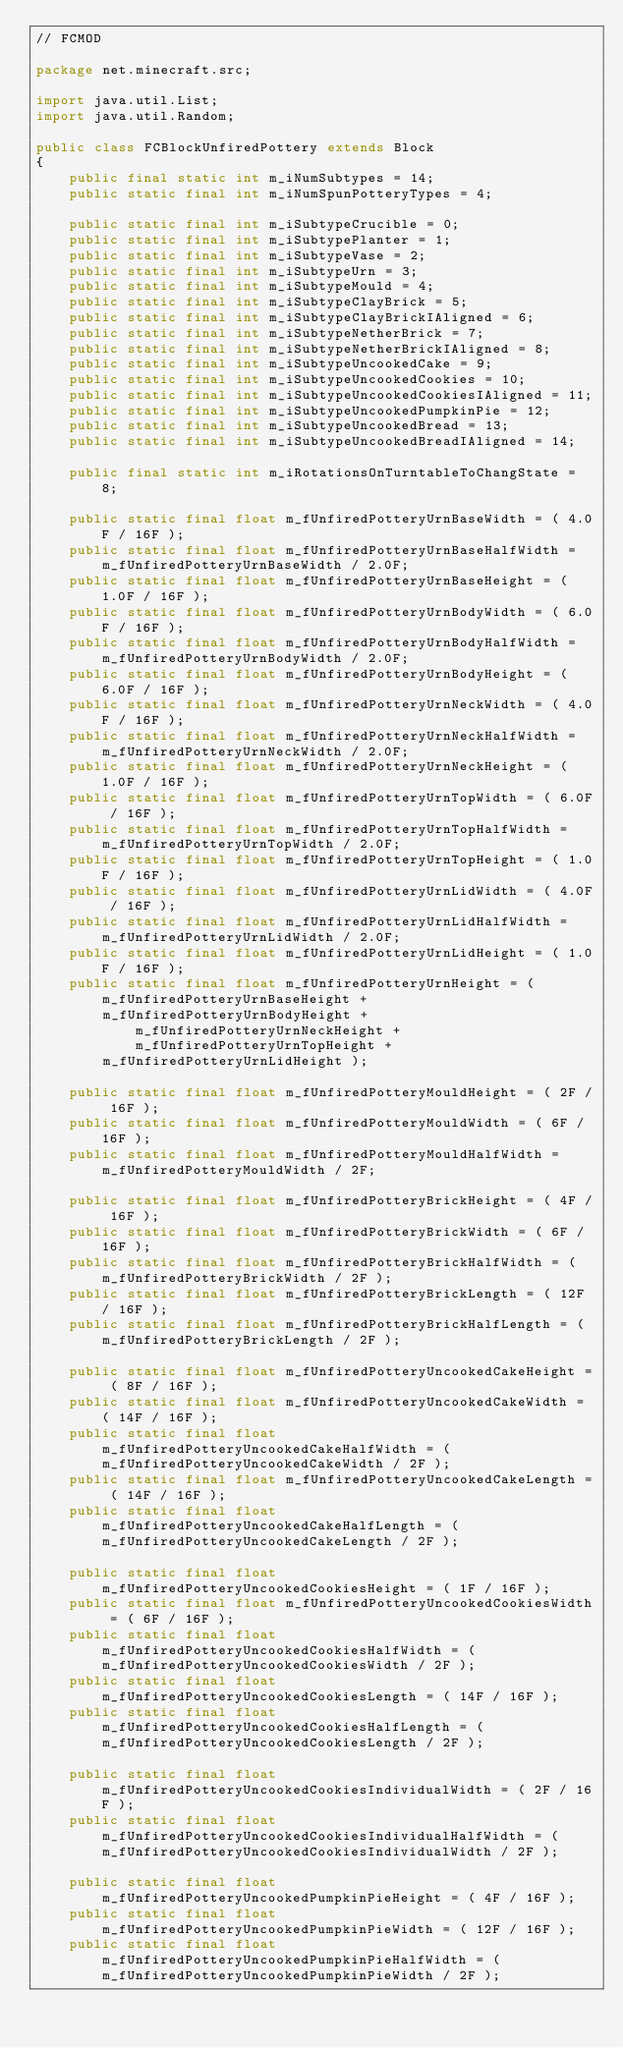Convert code to text. <code><loc_0><loc_0><loc_500><loc_500><_Java_>// FCMOD

package net.minecraft.src;

import java.util.List;
import java.util.Random;

public class FCBlockUnfiredPottery extends Block
{
    public final static int m_iNumSubtypes = 14;
    public static final int m_iNumSpunPotteryTypes = 4;    
    
    public static final int m_iSubtypeCrucible = 0;
    public static final int m_iSubtypePlanter = 1;
    public static final int m_iSubtypeVase = 2;
    public static final int m_iSubtypeUrn = 3;
    public static final int m_iSubtypeMould = 4;
    public static final int m_iSubtypeClayBrick = 5;
    public static final int m_iSubtypeClayBrickIAligned = 6;
    public static final int m_iSubtypeNetherBrick = 7;
    public static final int m_iSubtypeNetherBrickIAligned = 8;
    public static final int m_iSubtypeUncookedCake = 9;
    public static final int m_iSubtypeUncookedCookies = 10;
    public static final int m_iSubtypeUncookedCookiesIAligned = 11;
    public static final int m_iSubtypeUncookedPumpkinPie = 12;
    public static final int m_iSubtypeUncookedBread = 13;
    public static final int m_iSubtypeUncookedBreadIAligned = 14;
    
    public final static int m_iRotationsOnTurntableToChangState = 8;
    
	public static final float m_fUnfiredPotteryUrnBaseWidth = ( 4.0F / 16F );
	public static final float m_fUnfiredPotteryUrnBaseHalfWidth = m_fUnfiredPotteryUrnBaseWidth / 2.0F;
	public static final float m_fUnfiredPotteryUrnBaseHeight = ( 1.0F / 16F );
	public static final float m_fUnfiredPotteryUrnBodyWidth = ( 6.0F / 16F );
	public static final float m_fUnfiredPotteryUrnBodyHalfWidth = m_fUnfiredPotteryUrnBodyWidth / 2.0F;
	public static final float m_fUnfiredPotteryUrnBodyHeight = ( 6.0F / 16F );
	public static final float m_fUnfiredPotteryUrnNeckWidth = ( 4.0F / 16F );
	public static final float m_fUnfiredPotteryUrnNeckHalfWidth = m_fUnfiredPotteryUrnNeckWidth / 2.0F;
	public static final float m_fUnfiredPotteryUrnNeckHeight = ( 1.0F / 16F );
	public static final float m_fUnfiredPotteryUrnTopWidth = ( 6.0F / 16F );
	public static final float m_fUnfiredPotteryUrnTopHalfWidth = m_fUnfiredPotteryUrnTopWidth / 2.0F;
	public static final float m_fUnfiredPotteryUrnTopHeight = ( 1.0F / 16F );
	public static final float m_fUnfiredPotteryUrnLidWidth = ( 4.0F / 16F );
	public static final float m_fUnfiredPotteryUrnLidHalfWidth = m_fUnfiredPotteryUrnLidWidth / 2.0F;
	public static final float m_fUnfiredPotteryUrnLidHeight = ( 1.0F / 16F );
	public static final float m_fUnfiredPotteryUrnHeight = ( m_fUnfiredPotteryUrnBaseHeight + 
		m_fUnfiredPotteryUrnBodyHeight + m_fUnfiredPotteryUrnNeckHeight + m_fUnfiredPotteryUrnTopHeight +
		m_fUnfiredPotteryUrnLidHeight );
	
	public static final float m_fUnfiredPotteryMouldHeight = ( 2F / 16F );
	public static final float m_fUnfiredPotteryMouldWidth = ( 6F / 16F );
	public static final float m_fUnfiredPotteryMouldHalfWidth = m_fUnfiredPotteryMouldWidth / 2F;
	
	public static final float m_fUnfiredPotteryBrickHeight = ( 4F / 16F );
	public static final float m_fUnfiredPotteryBrickWidth = ( 6F / 16F );
	public static final float m_fUnfiredPotteryBrickHalfWidth = ( m_fUnfiredPotteryBrickWidth / 2F );
	public static final float m_fUnfiredPotteryBrickLength = ( 12F / 16F );
	public static final float m_fUnfiredPotteryBrickHalfLength = ( m_fUnfiredPotteryBrickLength / 2F );
	
	public static final float m_fUnfiredPotteryUncookedCakeHeight = ( 8F / 16F );
	public static final float m_fUnfiredPotteryUncookedCakeWidth = ( 14F / 16F );
	public static final float m_fUnfiredPotteryUncookedCakeHalfWidth = ( m_fUnfiredPotteryUncookedCakeWidth / 2F );
	public static final float m_fUnfiredPotteryUncookedCakeLength = ( 14F / 16F );
	public static final float m_fUnfiredPotteryUncookedCakeHalfLength = ( m_fUnfiredPotteryUncookedCakeLength / 2F );
	
	public static final float m_fUnfiredPotteryUncookedCookiesHeight = ( 1F / 16F );
	public static final float m_fUnfiredPotteryUncookedCookiesWidth = ( 6F / 16F );
	public static final float m_fUnfiredPotteryUncookedCookiesHalfWidth = ( m_fUnfiredPotteryUncookedCookiesWidth / 2F );
	public static final float m_fUnfiredPotteryUncookedCookiesLength = ( 14F / 16F );
	public static final float m_fUnfiredPotteryUncookedCookiesHalfLength = ( m_fUnfiredPotteryUncookedCookiesLength / 2F );
	
	public static final float m_fUnfiredPotteryUncookedCookiesIndividualWidth = ( 2F / 16F );
	public static final float m_fUnfiredPotteryUncookedCookiesIndividualHalfWidth = ( m_fUnfiredPotteryUncookedCookiesIndividualWidth / 2F );
	
	public static final float m_fUnfiredPotteryUncookedPumpkinPieHeight = ( 4F / 16F );
	public static final float m_fUnfiredPotteryUncookedPumpkinPieWidth = ( 12F / 16F );
	public static final float m_fUnfiredPotteryUncookedPumpkinPieHalfWidth = ( m_fUnfiredPotteryUncookedPumpkinPieWidth / 2F );</code> 